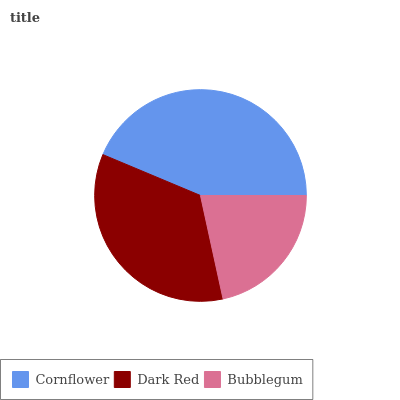Is Bubblegum the minimum?
Answer yes or no. Yes. Is Cornflower the maximum?
Answer yes or no. Yes. Is Dark Red the minimum?
Answer yes or no. No. Is Dark Red the maximum?
Answer yes or no. No. Is Cornflower greater than Dark Red?
Answer yes or no. Yes. Is Dark Red less than Cornflower?
Answer yes or no. Yes. Is Dark Red greater than Cornflower?
Answer yes or no. No. Is Cornflower less than Dark Red?
Answer yes or no. No. Is Dark Red the high median?
Answer yes or no. Yes. Is Dark Red the low median?
Answer yes or no. Yes. Is Bubblegum the high median?
Answer yes or no. No. Is Cornflower the low median?
Answer yes or no. No. 